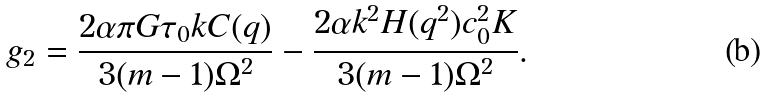Convert formula to latex. <formula><loc_0><loc_0><loc_500><loc_500>g _ { 2 } = \frac { 2 \alpha \pi G \tau _ { 0 } k C ( q ) } { 3 ( m - 1 ) \Omega ^ { 2 } } - \frac { 2 \alpha k ^ { 2 } H ( q ^ { 2 } ) c _ { 0 } ^ { 2 } K } { 3 ( m - 1 ) \Omega ^ { 2 } } .</formula> 